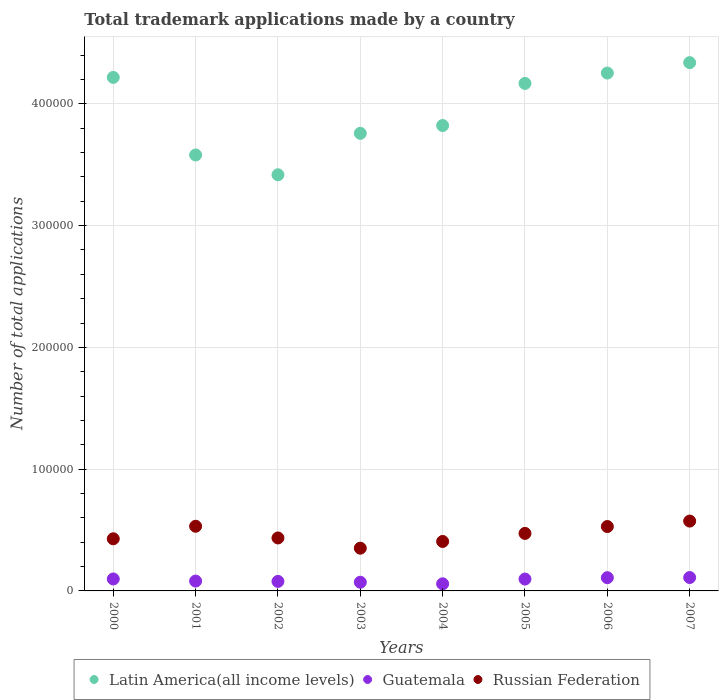Is the number of dotlines equal to the number of legend labels?
Keep it short and to the point. Yes. What is the number of applications made by in Russian Federation in 2004?
Make the answer very short. 4.06e+04. Across all years, what is the maximum number of applications made by in Russian Federation?
Provide a short and direct response. 5.73e+04. Across all years, what is the minimum number of applications made by in Russian Federation?
Your answer should be compact. 3.51e+04. In which year was the number of applications made by in Guatemala maximum?
Keep it short and to the point. 2007. What is the total number of applications made by in Guatemala in the graph?
Offer a very short reply. 7.03e+04. What is the difference between the number of applications made by in Guatemala in 2004 and that in 2006?
Make the answer very short. -5047. What is the difference between the number of applications made by in Russian Federation in 2003 and the number of applications made by in Latin America(all income levels) in 2000?
Offer a very short reply. -3.87e+05. What is the average number of applications made by in Russian Federation per year?
Give a very brief answer. 4.66e+04. In the year 2000, what is the difference between the number of applications made by in Guatemala and number of applications made by in Latin America(all income levels)?
Your response must be concise. -4.12e+05. What is the ratio of the number of applications made by in Latin America(all income levels) in 2001 to that in 2002?
Your answer should be very brief. 1.05. Is the difference between the number of applications made by in Guatemala in 2005 and 2007 greater than the difference between the number of applications made by in Latin America(all income levels) in 2005 and 2007?
Make the answer very short. Yes. What is the difference between the highest and the second highest number of applications made by in Guatemala?
Keep it short and to the point. 124. What is the difference between the highest and the lowest number of applications made by in Guatemala?
Your answer should be very brief. 5171. In how many years, is the number of applications made by in Russian Federation greater than the average number of applications made by in Russian Federation taken over all years?
Your answer should be very brief. 4. Is the sum of the number of applications made by in Latin America(all income levels) in 2002 and 2005 greater than the maximum number of applications made by in Russian Federation across all years?
Your answer should be very brief. Yes. Is the number of applications made by in Russian Federation strictly greater than the number of applications made by in Latin America(all income levels) over the years?
Give a very brief answer. No. Is the number of applications made by in Guatemala strictly less than the number of applications made by in Russian Federation over the years?
Offer a terse response. Yes. How many dotlines are there?
Your response must be concise. 3. How many years are there in the graph?
Give a very brief answer. 8. What is the difference between two consecutive major ticks on the Y-axis?
Give a very brief answer. 1.00e+05. Are the values on the major ticks of Y-axis written in scientific E-notation?
Your answer should be compact. No. Does the graph contain grids?
Provide a succinct answer. Yes. What is the title of the graph?
Make the answer very short. Total trademark applications made by a country. Does "Malawi" appear as one of the legend labels in the graph?
Make the answer very short. No. What is the label or title of the Y-axis?
Offer a terse response. Number of total applications. What is the Number of total applications of Latin America(all income levels) in 2000?
Your answer should be very brief. 4.22e+05. What is the Number of total applications in Guatemala in 2000?
Give a very brief answer. 9821. What is the Number of total applications of Russian Federation in 2000?
Your answer should be very brief. 4.28e+04. What is the Number of total applications of Latin America(all income levels) in 2001?
Provide a succinct answer. 3.58e+05. What is the Number of total applications of Guatemala in 2001?
Make the answer very short. 8088. What is the Number of total applications of Russian Federation in 2001?
Your response must be concise. 5.31e+04. What is the Number of total applications in Latin America(all income levels) in 2002?
Provide a short and direct response. 3.42e+05. What is the Number of total applications of Guatemala in 2002?
Provide a succinct answer. 7808. What is the Number of total applications of Russian Federation in 2002?
Make the answer very short. 4.35e+04. What is the Number of total applications of Latin America(all income levels) in 2003?
Give a very brief answer. 3.76e+05. What is the Number of total applications of Guatemala in 2003?
Keep it short and to the point. 7138. What is the Number of total applications in Russian Federation in 2003?
Give a very brief answer. 3.51e+04. What is the Number of total applications of Latin America(all income levels) in 2004?
Your answer should be compact. 3.82e+05. What is the Number of total applications of Guatemala in 2004?
Your answer should be compact. 5832. What is the Number of total applications of Russian Federation in 2004?
Provide a short and direct response. 4.06e+04. What is the Number of total applications in Latin America(all income levels) in 2005?
Keep it short and to the point. 4.17e+05. What is the Number of total applications in Guatemala in 2005?
Make the answer very short. 9743. What is the Number of total applications in Russian Federation in 2005?
Ensure brevity in your answer.  4.72e+04. What is the Number of total applications of Latin America(all income levels) in 2006?
Keep it short and to the point. 4.25e+05. What is the Number of total applications in Guatemala in 2006?
Keep it short and to the point. 1.09e+04. What is the Number of total applications in Russian Federation in 2006?
Provide a short and direct response. 5.29e+04. What is the Number of total applications in Latin America(all income levels) in 2007?
Ensure brevity in your answer.  4.34e+05. What is the Number of total applications of Guatemala in 2007?
Your answer should be compact. 1.10e+04. What is the Number of total applications in Russian Federation in 2007?
Give a very brief answer. 5.73e+04. Across all years, what is the maximum Number of total applications in Latin America(all income levels)?
Provide a succinct answer. 4.34e+05. Across all years, what is the maximum Number of total applications of Guatemala?
Your answer should be compact. 1.10e+04. Across all years, what is the maximum Number of total applications in Russian Federation?
Keep it short and to the point. 5.73e+04. Across all years, what is the minimum Number of total applications in Latin America(all income levels)?
Provide a short and direct response. 3.42e+05. Across all years, what is the minimum Number of total applications in Guatemala?
Offer a very short reply. 5832. Across all years, what is the minimum Number of total applications in Russian Federation?
Your answer should be very brief. 3.51e+04. What is the total Number of total applications of Latin America(all income levels) in the graph?
Your answer should be compact. 3.16e+06. What is the total Number of total applications of Guatemala in the graph?
Ensure brevity in your answer.  7.03e+04. What is the total Number of total applications of Russian Federation in the graph?
Provide a short and direct response. 3.73e+05. What is the difference between the Number of total applications of Latin America(all income levels) in 2000 and that in 2001?
Give a very brief answer. 6.37e+04. What is the difference between the Number of total applications of Guatemala in 2000 and that in 2001?
Offer a very short reply. 1733. What is the difference between the Number of total applications of Russian Federation in 2000 and that in 2001?
Make the answer very short. -1.03e+04. What is the difference between the Number of total applications in Latin America(all income levels) in 2000 and that in 2002?
Offer a terse response. 8.00e+04. What is the difference between the Number of total applications in Guatemala in 2000 and that in 2002?
Your answer should be very brief. 2013. What is the difference between the Number of total applications of Russian Federation in 2000 and that in 2002?
Your response must be concise. -680. What is the difference between the Number of total applications in Latin America(all income levels) in 2000 and that in 2003?
Make the answer very short. 4.59e+04. What is the difference between the Number of total applications of Guatemala in 2000 and that in 2003?
Give a very brief answer. 2683. What is the difference between the Number of total applications of Russian Federation in 2000 and that in 2003?
Your answer should be compact. 7723. What is the difference between the Number of total applications of Latin America(all income levels) in 2000 and that in 2004?
Offer a terse response. 3.95e+04. What is the difference between the Number of total applications in Guatemala in 2000 and that in 2004?
Give a very brief answer. 3989. What is the difference between the Number of total applications of Russian Federation in 2000 and that in 2004?
Offer a very short reply. 2203. What is the difference between the Number of total applications of Latin America(all income levels) in 2000 and that in 2005?
Provide a short and direct response. 4934. What is the difference between the Number of total applications of Russian Federation in 2000 and that in 2005?
Your answer should be very brief. -4408. What is the difference between the Number of total applications in Latin America(all income levels) in 2000 and that in 2006?
Provide a succinct answer. -3578. What is the difference between the Number of total applications of Guatemala in 2000 and that in 2006?
Offer a very short reply. -1058. What is the difference between the Number of total applications of Russian Federation in 2000 and that in 2006?
Provide a short and direct response. -1.01e+04. What is the difference between the Number of total applications in Latin America(all income levels) in 2000 and that in 2007?
Your answer should be very brief. -1.21e+04. What is the difference between the Number of total applications in Guatemala in 2000 and that in 2007?
Provide a succinct answer. -1182. What is the difference between the Number of total applications of Russian Federation in 2000 and that in 2007?
Offer a terse response. -1.45e+04. What is the difference between the Number of total applications in Latin America(all income levels) in 2001 and that in 2002?
Your answer should be compact. 1.63e+04. What is the difference between the Number of total applications in Guatemala in 2001 and that in 2002?
Keep it short and to the point. 280. What is the difference between the Number of total applications in Russian Federation in 2001 and that in 2002?
Your answer should be compact. 9602. What is the difference between the Number of total applications in Latin America(all income levels) in 2001 and that in 2003?
Offer a very short reply. -1.78e+04. What is the difference between the Number of total applications of Guatemala in 2001 and that in 2003?
Your answer should be compact. 950. What is the difference between the Number of total applications in Russian Federation in 2001 and that in 2003?
Your answer should be very brief. 1.80e+04. What is the difference between the Number of total applications of Latin America(all income levels) in 2001 and that in 2004?
Offer a very short reply. -2.42e+04. What is the difference between the Number of total applications of Guatemala in 2001 and that in 2004?
Your response must be concise. 2256. What is the difference between the Number of total applications in Russian Federation in 2001 and that in 2004?
Offer a very short reply. 1.25e+04. What is the difference between the Number of total applications of Latin America(all income levels) in 2001 and that in 2005?
Your answer should be very brief. -5.88e+04. What is the difference between the Number of total applications in Guatemala in 2001 and that in 2005?
Your answer should be compact. -1655. What is the difference between the Number of total applications in Russian Federation in 2001 and that in 2005?
Your response must be concise. 5874. What is the difference between the Number of total applications in Latin America(all income levels) in 2001 and that in 2006?
Your answer should be compact. -6.73e+04. What is the difference between the Number of total applications of Guatemala in 2001 and that in 2006?
Keep it short and to the point. -2791. What is the difference between the Number of total applications in Russian Federation in 2001 and that in 2006?
Keep it short and to the point. 229. What is the difference between the Number of total applications in Latin America(all income levels) in 2001 and that in 2007?
Your response must be concise. -7.58e+04. What is the difference between the Number of total applications of Guatemala in 2001 and that in 2007?
Make the answer very short. -2915. What is the difference between the Number of total applications in Russian Federation in 2001 and that in 2007?
Offer a terse response. -4250. What is the difference between the Number of total applications of Latin America(all income levels) in 2002 and that in 2003?
Your answer should be compact. -3.40e+04. What is the difference between the Number of total applications of Guatemala in 2002 and that in 2003?
Provide a short and direct response. 670. What is the difference between the Number of total applications of Russian Federation in 2002 and that in 2003?
Provide a short and direct response. 8403. What is the difference between the Number of total applications in Latin America(all income levels) in 2002 and that in 2004?
Your answer should be very brief. -4.04e+04. What is the difference between the Number of total applications of Guatemala in 2002 and that in 2004?
Keep it short and to the point. 1976. What is the difference between the Number of total applications in Russian Federation in 2002 and that in 2004?
Your answer should be very brief. 2883. What is the difference between the Number of total applications in Latin America(all income levels) in 2002 and that in 2005?
Make the answer very short. -7.50e+04. What is the difference between the Number of total applications of Guatemala in 2002 and that in 2005?
Your response must be concise. -1935. What is the difference between the Number of total applications in Russian Federation in 2002 and that in 2005?
Keep it short and to the point. -3728. What is the difference between the Number of total applications of Latin America(all income levels) in 2002 and that in 2006?
Give a very brief answer. -8.35e+04. What is the difference between the Number of total applications in Guatemala in 2002 and that in 2006?
Give a very brief answer. -3071. What is the difference between the Number of total applications in Russian Federation in 2002 and that in 2006?
Offer a terse response. -9373. What is the difference between the Number of total applications in Latin America(all income levels) in 2002 and that in 2007?
Give a very brief answer. -9.21e+04. What is the difference between the Number of total applications of Guatemala in 2002 and that in 2007?
Provide a succinct answer. -3195. What is the difference between the Number of total applications of Russian Federation in 2002 and that in 2007?
Keep it short and to the point. -1.39e+04. What is the difference between the Number of total applications of Latin America(all income levels) in 2003 and that in 2004?
Your response must be concise. -6410. What is the difference between the Number of total applications in Guatemala in 2003 and that in 2004?
Offer a terse response. 1306. What is the difference between the Number of total applications of Russian Federation in 2003 and that in 2004?
Keep it short and to the point. -5520. What is the difference between the Number of total applications of Latin America(all income levels) in 2003 and that in 2005?
Your answer should be very brief. -4.10e+04. What is the difference between the Number of total applications of Guatemala in 2003 and that in 2005?
Keep it short and to the point. -2605. What is the difference between the Number of total applications of Russian Federation in 2003 and that in 2005?
Keep it short and to the point. -1.21e+04. What is the difference between the Number of total applications in Latin America(all income levels) in 2003 and that in 2006?
Provide a succinct answer. -4.95e+04. What is the difference between the Number of total applications of Guatemala in 2003 and that in 2006?
Make the answer very short. -3741. What is the difference between the Number of total applications in Russian Federation in 2003 and that in 2006?
Make the answer very short. -1.78e+04. What is the difference between the Number of total applications of Latin America(all income levels) in 2003 and that in 2007?
Provide a succinct answer. -5.81e+04. What is the difference between the Number of total applications of Guatemala in 2003 and that in 2007?
Give a very brief answer. -3865. What is the difference between the Number of total applications in Russian Federation in 2003 and that in 2007?
Your response must be concise. -2.23e+04. What is the difference between the Number of total applications of Latin America(all income levels) in 2004 and that in 2005?
Provide a succinct answer. -3.46e+04. What is the difference between the Number of total applications of Guatemala in 2004 and that in 2005?
Give a very brief answer. -3911. What is the difference between the Number of total applications of Russian Federation in 2004 and that in 2005?
Your answer should be very brief. -6611. What is the difference between the Number of total applications in Latin America(all income levels) in 2004 and that in 2006?
Keep it short and to the point. -4.31e+04. What is the difference between the Number of total applications of Guatemala in 2004 and that in 2006?
Make the answer very short. -5047. What is the difference between the Number of total applications in Russian Federation in 2004 and that in 2006?
Provide a succinct answer. -1.23e+04. What is the difference between the Number of total applications in Latin America(all income levels) in 2004 and that in 2007?
Provide a succinct answer. -5.16e+04. What is the difference between the Number of total applications in Guatemala in 2004 and that in 2007?
Give a very brief answer. -5171. What is the difference between the Number of total applications in Russian Federation in 2004 and that in 2007?
Give a very brief answer. -1.67e+04. What is the difference between the Number of total applications in Latin America(all income levels) in 2005 and that in 2006?
Give a very brief answer. -8512. What is the difference between the Number of total applications in Guatemala in 2005 and that in 2006?
Your response must be concise. -1136. What is the difference between the Number of total applications of Russian Federation in 2005 and that in 2006?
Your answer should be very brief. -5645. What is the difference between the Number of total applications in Latin America(all income levels) in 2005 and that in 2007?
Provide a short and direct response. -1.71e+04. What is the difference between the Number of total applications in Guatemala in 2005 and that in 2007?
Offer a terse response. -1260. What is the difference between the Number of total applications of Russian Federation in 2005 and that in 2007?
Provide a short and direct response. -1.01e+04. What is the difference between the Number of total applications in Latin America(all income levels) in 2006 and that in 2007?
Make the answer very short. -8557. What is the difference between the Number of total applications of Guatemala in 2006 and that in 2007?
Your answer should be compact. -124. What is the difference between the Number of total applications of Russian Federation in 2006 and that in 2007?
Make the answer very short. -4479. What is the difference between the Number of total applications in Latin America(all income levels) in 2000 and the Number of total applications in Guatemala in 2001?
Give a very brief answer. 4.14e+05. What is the difference between the Number of total applications in Latin America(all income levels) in 2000 and the Number of total applications in Russian Federation in 2001?
Provide a short and direct response. 3.69e+05. What is the difference between the Number of total applications of Guatemala in 2000 and the Number of total applications of Russian Federation in 2001?
Offer a very short reply. -4.33e+04. What is the difference between the Number of total applications of Latin America(all income levels) in 2000 and the Number of total applications of Guatemala in 2002?
Offer a terse response. 4.14e+05. What is the difference between the Number of total applications of Latin America(all income levels) in 2000 and the Number of total applications of Russian Federation in 2002?
Provide a short and direct response. 3.78e+05. What is the difference between the Number of total applications of Guatemala in 2000 and the Number of total applications of Russian Federation in 2002?
Keep it short and to the point. -3.37e+04. What is the difference between the Number of total applications of Latin America(all income levels) in 2000 and the Number of total applications of Guatemala in 2003?
Offer a terse response. 4.15e+05. What is the difference between the Number of total applications of Latin America(all income levels) in 2000 and the Number of total applications of Russian Federation in 2003?
Your answer should be very brief. 3.87e+05. What is the difference between the Number of total applications in Guatemala in 2000 and the Number of total applications in Russian Federation in 2003?
Your answer should be compact. -2.53e+04. What is the difference between the Number of total applications of Latin America(all income levels) in 2000 and the Number of total applications of Guatemala in 2004?
Your response must be concise. 4.16e+05. What is the difference between the Number of total applications of Latin America(all income levels) in 2000 and the Number of total applications of Russian Federation in 2004?
Your answer should be very brief. 3.81e+05. What is the difference between the Number of total applications in Guatemala in 2000 and the Number of total applications in Russian Federation in 2004?
Ensure brevity in your answer.  -3.08e+04. What is the difference between the Number of total applications in Latin America(all income levels) in 2000 and the Number of total applications in Guatemala in 2005?
Keep it short and to the point. 4.12e+05. What is the difference between the Number of total applications in Latin America(all income levels) in 2000 and the Number of total applications in Russian Federation in 2005?
Provide a succinct answer. 3.74e+05. What is the difference between the Number of total applications in Guatemala in 2000 and the Number of total applications in Russian Federation in 2005?
Keep it short and to the point. -3.74e+04. What is the difference between the Number of total applications in Latin America(all income levels) in 2000 and the Number of total applications in Guatemala in 2006?
Provide a short and direct response. 4.11e+05. What is the difference between the Number of total applications in Latin America(all income levels) in 2000 and the Number of total applications in Russian Federation in 2006?
Give a very brief answer. 3.69e+05. What is the difference between the Number of total applications of Guatemala in 2000 and the Number of total applications of Russian Federation in 2006?
Your answer should be compact. -4.30e+04. What is the difference between the Number of total applications of Latin America(all income levels) in 2000 and the Number of total applications of Guatemala in 2007?
Provide a succinct answer. 4.11e+05. What is the difference between the Number of total applications of Latin America(all income levels) in 2000 and the Number of total applications of Russian Federation in 2007?
Keep it short and to the point. 3.64e+05. What is the difference between the Number of total applications in Guatemala in 2000 and the Number of total applications in Russian Federation in 2007?
Give a very brief answer. -4.75e+04. What is the difference between the Number of total applications in Latin America(all income levels) in 2001 and the Number of total applications in Guatemala in 2002?
Your answer should be very brief. 3.50e+05. What is the difference between the Number of total applications of Latin America(all income levels) in 2001 and the Number of total applications of Russian Federation in 2002?
Your answer should be compact. 3.14e+05. What is the difference between the Number of total applications in Guatemala in 2001 and the Number of total applications in Russian Federation in 2002?
Your response must be concise. -3.54e+04. What is the difference between the Number of total applications in Latin America(all income levels) in 2001 and the Number of total applications in Guatemala in 2003?
Your answer should be very brief. 3.51e+05. What is the difference between the Number of total applications in Latin America(all income levels) in 2001 and the Number of total applications in Russian Federation in 2003?
Your answer should be very brief. 3.23e+05. What is the difference between the Number of total applications in Guatemala in 2001 and the Number of total applications in Russian Federation in 2003?
Keep it short and to the point. -2.70e+04. What is the difference between the Number of total applications of Latin America(all income levels) in 2001 and the Number of total applications of Guatemala in 2004?
Offer a terse response. 3.52e+05. What is the difference between the Number of total applications of Latin America(all income levels) in 2001 and the Number of total applications of Russian Federation in 2004?
Make the answer very short. 3.17e+05. What is the difference between the Number of total applications of Guatemala in 2001 and the Number of total applications of Russian Federation in 2004?
Provide a short and direct response. -3.25e+04. What is the difference between the Number of total applications of Latin America(all income levels) in 2001 and the Number of total applications of Guatemala in 2005?
Offer a very short reply. 3.48e+05. What is the difference between the Number of total applications of Latin America(all income levels) in 2001 and the Number of total applications of Russian Federation in 2005?
Provide a short and direct response. 3.11e+05. What is the difference between the Number of total applications of Guatemala in 2001 and the Number of total applications of Russian Federation in 2005?
Ensure brevity in your answer.  -3.91e+04. What is the difference between the Number of total applications in Latin America(all income levels) in 2001 and the Number of total applications in Guatemala in 2006?
Give a very brief answer. 3.47e+05. What is the difference between the Number of total applications of Latin America(all income levels) in 2001 and the Number of total applications of Russian Federation in 2006?
Your response must be concise. 3.05e+05. What is the difference between the Number of total applications of Guatemala in 2001 and the Number of total applications of Russian Federation in 2006?
Give a very brief answer. -4.48e+04. What is the difference between the Number of total applications of Latin America(all income levels) in 2001 and the Number of total applications of Guatemala in 2007?
Your answer should be compact. 3.47e+05. What is the difference between the Number of total applications in Latin America(all income levels) in 2001 and the Number of total applications in Russian Federation in 2007?
Provide a short and direct response. 3.01e+05. What is the difference between the Number of total applications in Guatemala in 2001 and the Number of total applications in Russian Federation in 2007?
Offer a very short reply. -4.93e+04. What is the difference between the Number of total applications in Latin America(all income levels) in 2002 and the Number of total applications in Guatemala in 2003?
Offer a very short reply. 3.35e+05. What is the difference between the Number of total applications of Latin America(all income levels) in 2002 and the Number of total applications of Russian Federation in 2003?
Provide a short and direct response. 3.07e+05. What is the difference between the Number of total applications in Guatemala in 2002 and the Number of total applications in Russian Federation in 2003?
Offer a terse response. -2.73e+04. What is the difference between the Number of total applications of Latin America(all income levels) in 2002 and the Number of total applications of Guatemala in 2004?
Offer a very short reply. 3.36e+05. What is the difference between the Number of total applications of Latin America(all income levels) in 2002 and the Number of total applications of Russian Federation in 2004?
Provide a succinct answer. 3.01e+05. What is the difference between the Number of total applications of Guatemala in 2002 and the Number of total applications of Russian Federation in 2004?
Your answer should be very brief. -3.28e+04. What is the difference between the Number of total applications of Latin America(all income levels) in 2002 and the Number of total applications of Guatemala in 2005?
Your response must be concise. 3.32e+05. What is the difference between the Number of total applications in Latin America(all income levels) in 2002 and the Number of total applications in Russian Federation in 2005?
Ensure brevity in your answer.  2.94e+05. What is the difference between the Number of total applications of Guatemala in 2002 and the Number of total applications of Russian Federation in 2005?
Ensure brevity in your answer.  -3.94e+04. What is the difference between the Number of total applications in Latin America(all income levels) in 2002 and the Number of total applications in Guatemala in 2006?
Provide a succinct answer. 3.31e+05. What is the difference between the Number of total applications in Latin America(all income levels) in 2002 and the Number of total applications in Russian Federation in 2006?
Offer a terse response. 2.89e+05. What is the difference between the Number of total applications of Guatemala in 2002 and the Number of total applications of Russian Federation in 2006?
Your answer should be compact. -4.51e+04. What is the difference between the Number of total applications in Latin America(all income levels) in 2002 and the Number of total applications in Guatemala in 2007?
Keep it short and to the point. 3.31e+05. What is the difference between the Number of total applications in Latin America(all income levels) in 2002 and the Number of total applications in Russian Federation in 2007?
Your response must be concise. 2.84e+05. What is the difference between the Number of total applications of Guatemala in 2002 and the Number of total applications of Russian Federation in 2007?
Your answer should be compact. -4.95e+04. What is the difference between the Number of total applications of Latin America(all income levels) in 2003 and the Number of total applications of Guatemala in 2004?
Your response must be concise. 3.70e+05. What is the difference between the Number of total applications of Latin America(all income levels) in 2003 and the Number of total applications of Russian Federation in 2004?
Your response must be concise. 3.35e+05. What is the difference between the Number of total applications of Guatemala in 2003 and the Number of total applications of Russian Federation in 2004?
Make the answer very short. -3.35e+04. What is the difference between the Number of total applications in Latin America(all income levels) in 2003 and the Number of total applications in Guatemala in 2005?
Your answer should be very brief. 3.66e+05. What is the difference between the Number of total applications in Latin America(all income levels) in 2003 and the Number of total applications in Russian Federation in 2005?
Give a very brief answer. 3.29e+05. What is the difference between the Number of total applications in Guatemala in 2003 and the Number of total applications in Russian Federation in 2005?
Your answer should be compact. -4.01e+04. What is the difference between the Number of total applications of Latin America(all income levels) in 2003 and the Number of total applications of Guatemala in 2006?
Ensure brevity in your answer.  3.65e+05. What is the difference between the Number of total applications of Latin America(all income levels) in 2003 and the Number of total applications of Russian Federation in 2006?
Offer a very short reply. 3.23e+05. What is the difference between the Number of total applications of Guatemala in 2003 and the Number of total applications of Russian Federation in 2006?
Provide a succinct answer. -4.57e+04. What is the difference between the Number of total applications of Latin America(all income levels) in 2003 and the Number of total applications of Guatemala in 2007?
Ensure brevity in your answer.  3.65e+05. What is the difference between the Number of total applications in Latin America(all income levels) in 2003 and the Number of total applications in Russian Federation in 2007?
Keep it short and to the point. 3.18e+05. What is the difference between the Number of total applications of Guatemala in 2003 and the Number of total applications of Russian Federation in 2007?
Provide a short and direct response. -5.02e+04. What is the difference between the Number of total applications in Latin America(all income levels) in 2004 and the Number of total applications in Guatemala in 2005?
Ensure brevity in your answer.  3.72e+05. What is the difference between the Number of total applications in Latin America(all income levels) in 2004 and the Number of total applications in Russian Federation in 2005?
Give a very brief answer. 3.35e+05. What is the difference between the Number of total applications in Guatemala in 2004 and the Number of total applications in Russian Federation in 2005?
Keep it short and to the point. -4.14e+04. What is the difference between the Number of total applications of Latin America(all income levels) in 2004 and the Number of total applications of Guatemala in 2006?
Provide a short and direct response. 3.71e+05. What is the difference between the Number of total applications of Latin America(all income levels) in 2004 and the Number of total applications of Russian Federation in 2006?
Your response must be concise. 3.29e+05. What is the difference between the Number of total applications in Guatemala in 2004 and the Number of total applications in Russian Federation in 2006?
Give a very brief answer. -4.70e+04. What is the difference between the Number of total applications of Latin America(all income levels) in 2004 and the Number of total applications of Guatemala in 2007?
Offer a very short reply. 3.71e+05. What is the difference between the Number of total applications in Latin America(all income levels) in 2004 and the Number of total applications in Russian Federation in 2007?
Offer a very short reply. 3.25e+05. What is the difference between the Number of total applications of Guatemala in 2004 and the Number of total applications of Russian Federation in 2007?
Provide a short and direct response. -5.15e+04. What is the difference between the Number of total applications of Latin America(all income levels) in 2005 and the Number of total applications of Guatemala in 2006?
Your answer should be compact. 4.06e+05. What is the difference between the Number of total applications of Latin America(all income levels) in 2005 and the Number of total applications of Russian Federation in 2006?
Your answer should be compact. 3.64e+05. What is the difference between the Number of total applications of Guatemala in 2005 and the Number of total applications of Russian Federation in 2006?
Your answer should be very brief. -4.31e+04. What is the difference between the Number of total applications of Latin America(all income levels) in 2005 and the Number of total applications of Guatemala in 2007?
Provide a short and direct response. 4.06e+05. What is the difference between the Number of total applications in Latin America(all income levels) in 2005 and the Number of total applications in Russian Federation in 2007?
Keep it short and to the point. 3.59e+05. What is the difference between the Number of total applications in Guatemala in 2005 and the Number of total applications in Russian Federation in 2007?
Give a very brief answer. -4.76e+04. What is the difference between the Number of total applications of Latin America(all income levels) in 2006 and the Number of total applications of Guatemala in 2007?
Offer a very short reply. 4.14e+05. What is the difference between the Number of total applications of Latin America(all income levels) in 2006 and the Number of total applications of Russian Federation in 2007?
Offer a terse response. 3.68e+05. What is the difference between the Number of total applications of Guatemala in 2006 and the Number of total applications of Russian Federation in 2007?
Provide a short and direct response. -4.65e+04. What is the average Number of total applications in Latin America(all income levels) per year?
Provide a succinct answer. 3.94e+05. What is the average Number of total applications in Guatemala per year?
Provide a succinct answer. 8789. What is the average Number of total applications in Russian Federation per year?
Keep it short and to the point. 4.66e+04. In the year 2000, what is the difference between the Number of total applications in Latin America(all income levels) and Number of total applications in Guatemala?
Your response must be concise. 4.12e+05. In the year 2000, what is the difference between the Number of total applications of Latin America(all income levels) and Number of total applications of Russian Federation?
Your answer should be very brief. 3.79e+05. In the year 2000, what is the difference between the Number of total applications of Guatemala and Number of total applications of Russian Federation?
Your answer should be compact. -3.30e+04. In the year 2001, what is the difference between the Number of total applications of Latin America(all income levels) and Number of total applications of Guatemala?
Keep it short and to the point. 3.50e+05. In the year 2001, what is the difference between the Number of total applications in Latin America(all income levels) and Number of total applications in Russian Federation?
Provide a short and direct response. 3.05e+05. In the year 2001, what is the difference between the Number of total applications of Guatemala and Number of total applications of Russian Federation?
Give a very brief answer. -4.50e+04. In the year 2002, what is the difference between the Number of total applications in Latin America(all income levels) and Number of total applications in Guatemala?
Provide a succinct answer. 3.34e+05. In the year 2002, what is the difference between the Number of total applications in Latin America(all income levels) and Number of total applications in Russian Federation?
Provide a short and direct response. 2.98e+05. In the year 2002, what is the difference between the Number of total applications in Guatemala and Number of total applications in Russian Federation?
Give a very brief answer. -3.57e+04. In the year 2003, what is the difference between the Number of total applications of Latin America(all income levels) and Number of total applications of Guatemala?
Provide a succinct answer. 3.69e+05. In the year 2003, what is the difference between the Number of total applications of Latin America(all income levels) and Number of total applications of Russian Federation?
Your response must be concise. 3.41e+05. In the year 2003, what is the difference between the Number of total applications of Guatemala and Number of total applications of Russian Federation?
Offer a terse response. -2.80e+04. In the year 2004, what is the difference between the Number of total applications in Latin America(all income levels) and Number of total applications in Guatemala?
Provide a succinct answer. 3.76e+05. In the year 2004, what is the difference between the Number of total applications of Latin America(all income levels) and Number of total applications of Russian Federation?
Your response must be concise. 3.42e+05. In the year 2004, what is the difference between the Number of total applications of Guatemala and Number of total applications of Russian Federation?
Your answer should be very brief. -3.48e+04. In the year 2005, what is the difference between the Number of total applications of Latin America(all income levels) and Number of total applications of Guatemala?
Ensure brevity in your answer.  4.07e+05. In the year 2005, what is the difference between the Number of total applications of Latin America(all income levels) and Number of total applications of Russian Federation?
Your answer should be compact. 3.70e+05. In the year 2005, what is the difference between the Number of total applications in Guatemala and Number of total applications in Russian Federation?
Offer a terse response. -3.75e+04. In the year 2006, what is the difference between the Number of total applications in Latin America(all income levels) and Number of total applications in Guatemala?
Offer a very short reply. 4.14e+05. In the year 2006, what is the difference between the Number of total applications in Latin America(all income levels) and Number of total applications in Russian Federation?
Make the answer very short. 3.72e+05. In the year 2006, what is the difference between the Number of total applications of Guatemala and Number of total applications of Russian Federation?
Provide a short and direct response. -4.20e+04. In the year 2007, what is the difference between the Number of total applications of Latin America(all income levels) and Number of total applications of Guatemala?
Keep it short and to the point. 4.23e+05. In the year 2007, what is the difference between the Number of total applications of Latin America(all income levels) and Number of total applications of Russian Federation?
Offer a very short reply. 3.76e+05. In the year 2007, what is the difference between the Number of total applications of Guatemala and Number of total applications of Russian Federation?
Make the answer very short. -4.63e+04. What is the ratio of the Number of total applications of Latin America(all income levels) in 2000 to that in 2001?
Provide a succinct answer. 1.18. What is the ratio of the Number of total applications of Guatemala in 2000 to that in 2001?
Provide a succinct answer. 1.21. What is the ratio of the Number of total applications in Russian Federation in 2000 to that in 2001?
Offer a terse response. 0.81. What is the ratio of the Number of total applications in Latin America(all income levels) in 2000 to that in 2002?
Your answer should be very brief. 1.23. What is the ratio of the Number of total applications in Guatemala in 2000 to that in 2002?
Provide a short and direct response. 1.26. What is the ratio of the Number of total applications in Russian Federation in 2000 to that in 2002?
Your response must be concise. 0.98. What is the ratio of the Number of total applications of Latin America(all income levels) in 2000 to that in 2003?
Provide a succinct answer. 1.12. What is the ratio of the Number of total applications of Guatemala in 2000 to that in 2003?
Your response must be concise. 1.38. What is the ratio of the Number of total applications in Russian Federation in 2000 to that in 2003?
Give a very brief answer. 1.22. What is the ratio of the Number of total applications of Latin America(all income levels) in 2000 to that in 2004?
Keep it short and to the point. 1.1. What is the ratio of the Number of total applications in Guatemala in 2000 to that in 2004?
Offer a terse response. 1.68. What is the ratio of the Number of total applications of Russian Federation in 2000 to that in 2004?
Ensure brevity in your answer.  1.05. What is the ratio of the Number of total applications of Latin America(all income levels) in 2000 to that in 2005?
Your answer should be compact. 1.01. What is the ratio of the Number of total applications of Russian Federation in 2000 to that in 2005?
Your answer should be compact. 0.91. What is the ratio of the Number of total applications in Guatemala in 2000 to that in 2006?
Your answer should be very brief. 0.9. What is the ratio of the Number of total applications of Russian Federation in 2000 to that in 2006?
Ensure brevity in your answer.  0.81. What is the ratio of the Number of total applications of Latin America(all income levels) in 2000 to that in 2007?
Your answer should be very brief. 0.97. What is the ratio of the Number of total applications of Guatemala in 2000 to that in 2007?
Keep it short and to the point. 0.89. What is the ratio of the Number of total applications of Russian Federation in 2000 to that in 2007?
Your answer should be very brief. 0.75. What is the ratio of the Number of total applications of Latin America(all income levels) in 2001 to that in 2002?
Provide a succinct answer. 1.05. What is the ratio of the Number of total applications in Guatemala in 2001 to that in 2002?
Offer a terse response. 1.04. What is the ratio of the Number of total applications in Russian Federation in 2001 to that in 2002?
Give a very brief answer. 1.22. What is the ratio of the Number of total applications of Latin America(all income levels) in 2001 to that in 2003?
Offer a terse response. 0.95. What is the ratio of the Number of total applications of Guatemala in 2001 to that in 2003?
Keep it short and to the point. 1.13. What is the ratio of the Number of total applications of Russian Federation in 2001 to that in 2003?
Ensure brevity in your answer.  1.51. What is the ratio of the Number of total applications in Latin America(all income levels) in 2001 to that in 2004?
Your answer should be very brief. 0.94. What is the ratio of the Number of total applications in Guatemala in 2001 to that in 2004?
Your answer should be compact. 1.39. What is the ratio of the Number of total applications in Russian Federation in 2001 to that in 2004?
Ensure brevity in your answer.  1.31. What is the ratio of the Number of total applications in Latin America(all income levels) in 2001 to that in 2005?
Your answer should be compact. 0.86. What is the ratio of the Number of total applications of Guatemala in 2001 to that in 2005?
Offer a very short reply. 0.83. What is the ratio of the Number of total applications of Russian Federation in 2001 to that in 2005?
Your response must be concise. 1.12. What is the ratio of the Number of total applications in Latin America(all income levels) in 2001 to that in 2006?
Make the answer very short. 0.84. What is the ratio of the Number of total applications of Guatemala in 2001 to that in 2006?
Provide a short and direct response. 0.74. What is the ratio of the Number of total applications of Latin America(all income levels) in 2001 to that in 2007?
Give a very brief answer. 0.83. What is the ratio of the Number of total applications of Guatemala in 2001 to that in 2007?
Give a very brief answer. 0.74. What is the ratio of the Number of total applications of Russian Federation in 2001 to that in 2007?
Your answer should be compact. 0.93. What is the ratio of the Number of total applications in Latin America(all income levels) in 2002 to that in 2003?
Ensure brevity in your answer.  0.91. What is the ratio of the Number of total applications of Guatemala in 2002 to that in 2003?
Provide a succinct answer. 1.09. What is the ratio of the Number of total applications of Russian Federation in 2002 to that in 2003?
Keep it short and to the point. 1.24. What is the ratio of the Number of total applications in Latin America(all income levels) in 2002 to that in 2004?
Ensure brevity in your answer.  0.89. What is the ratio of the Number of total applications in Guatemala in 2002 to that in 2004?
Your response must be concise. 1.34. What is the ratio of the Number of total applications in Russian Federation in 2002 to that in 2004?
Your response must be concise. 1.07. What is the ratio of the Number of total applications of Latin America(all income levels) in 2002 to that in 2005?
Provide a succinct answer. 0.82. What is the ratio of the Number of total applications of Guatemala in 2002 to that in 2005?
Offer a very short reply. 0.8. What is the ratio of the Number of total applications of Russian Federation in 2002 to that in 2005?
Make the answer very short. 0.92. What is the ratio of the Number of total applications of Latin America(all income levels) in 2002 to that in 2006?
Your answer should be compact. 0.8. What is the ratio of the Number of total applications in Guatemala in 2002 to that in 2006?
Offer a very short reply. 0.72. What is the ratio of the Number of total applications of Russian Federation in 2002 to that in 2006?
Offer a very short reply. 0.82. What is the ratio of the Number of total applications of Latin America(all income levels) in 2002 to that in 2007?
Offer a terse response. 0.79. What is the ratio of the Number of total applications of Guatemala in 2002 to that in 2007?
Provide a succinct answer. 0.71. What is the ratio of the Number of total applications of Russian Federation in 2002 to that in 2007?
Offer a very short reply. 0.76. What is the ratio of the Number of total applications of Latin America(all income levels) in 2003 to that in 2004?
Make the answer very short. 0.98. What is the ratio of the Number of total applications of Guatemala in 2003 to that in 2004?
Provide a succinct answer. 1.22. What is the ratio of the Number of total applications in Russian Federation in 2003 to that in 2004?
Provide a succinct answer. 0.86. What is the ratio of the Number of total applications of Latin America(all income levels) in 2003 to that in 2005?
Offer a very short reply. 0.9. What is the ratio of the Number of total applications in Guatemala in 2003 to that in 2005?
Give a very brief answer. 0.73. What is the ratio of the Number of total applications of Russian Federation in 2003 to that in 2005?
Ensure brevity in your answer.  0.74. What is the ratio of the Number of total applications in Latin America(all income levels) in 2003 to that in 2006?
Ensure brevity in your answer.  0.88. What is the ratio of the Number of total applications of Guatemala in 2003 to that in 2006?
Provide a succinct answer. 0.66. What is the ratio of the Number of total applications in Russian Federation in 2003 to that in 2006?
Provide a short and direct response. 0.66. What is the ratio of the Number of total applications of Latin America(all income levels) in 2003 to that in 2007?
Offer a terse response. 0.87. What is the ratio of the Number of total applications in Guatemala in 2003 to that in 2007?
Offer a terse response. 0.65. What is the ratio of the Number of total applications in Russian Federation in 2003 to that in 2007?
Provide a short and direct response. 0.61. What is the ratio of the Number of total applications of Latin America(all income levels) in 2004 to that in 2005?
Provide a succinct answer. 0.92. What is the ratio of the Number of total applications of Guatemala in 2004 to that in 2005?
Give a very brief answer. 0.6. What is the ratio of the Number of total applications of Russian Federation in 2004 to that in 2005?
Keep it short and to the point. 0.86. What is the ratio of the Number of total applications of Latin America(all income levels) in 2004 to that in 2006?
Provide a short and direct response. 0.9. What is the ratio of the Number of total applications in Guatemala in 2004 to that in 2006?
Your answer should be very brief. 0.54. What is the ratio of the Number of total applications in Russian Federation in 2004 to that in 2006?
Your response must be concise. 0.77. What is the ratio of the Number of total applications in Latin America(all income levels) in 2004 to that in 2007?
Make the answer very short. 0.88. What is the ratio of the Number of total applications in Guatemala in 2004 to that in 2007?
Your answer should be very brief. 0.53. What is the ratio of the Number of total applications of Russian Federation in 2004 to that in 2007?
Ensure brevity in your answer.  0.71. What is the ratio of the Number of total applications of Latin America(all income levels) in 2005 to that in 2006?
Your response must be concise. 0.98. What is the ratio of the Number of total applications of Guatemala in 2005 to that in 2006?
Offer a terse response. 0.9. What is the ratio of the Number of total applications of Russian Federation in 2005 to that in 2006?
Provide a short and direct response. 0.89. What is the ratio of the Number of total applications of Latin America(all income levels) in 2005 to that in 2007?
Provide a short and direct response. 0.96. What is the ratio of the Number of total applications in Guatemala in 2005 to that in 2007?
Ensure brevity in your answer.  0.89. What is the ratio of the Number of total applications of Russian Federation in 2005 to that in 2007?
Make the answer very short. 0.82. What is the ratio of the Number of total applications in Latin America(all income levels) in 2006 to that in 2007?
Ensure brevity in your answer.  0.98. What is the ratio of the Number of total applications in Guatemala in 2006 to that in 2007?
Provide a short and direct response. 0.99. What is the ratio of the Number of total applications in Russian Federation in 2006 to that in 2007?
Your answer should be very brief. 0.92. What is the difference between the highest and the second highest Number of total applications of Latin America(all income levels)?
Ensure brevity in your answer.  8557. What is the difference between the highest and the second highest Number of total applications in Guatemala?
Offer a very short reply. 124. What is the difference between the highest and the second highest Number of total applications in Russian Federation?
Provide a short and direct response. 4250. What is the difference between the highest and the lowest Number of total applications in Latin America(all income levels)?
Ensure brevity in your answer.  9.21e+04. What is the difference between the highest and the lowest Number of total applications in Guatemala?
Your answer should be compact. 5171. What is the difference between the highest and the lowest Number of total applications of Russian Federation?
Provide a succinct answer. 2.23e+04. 